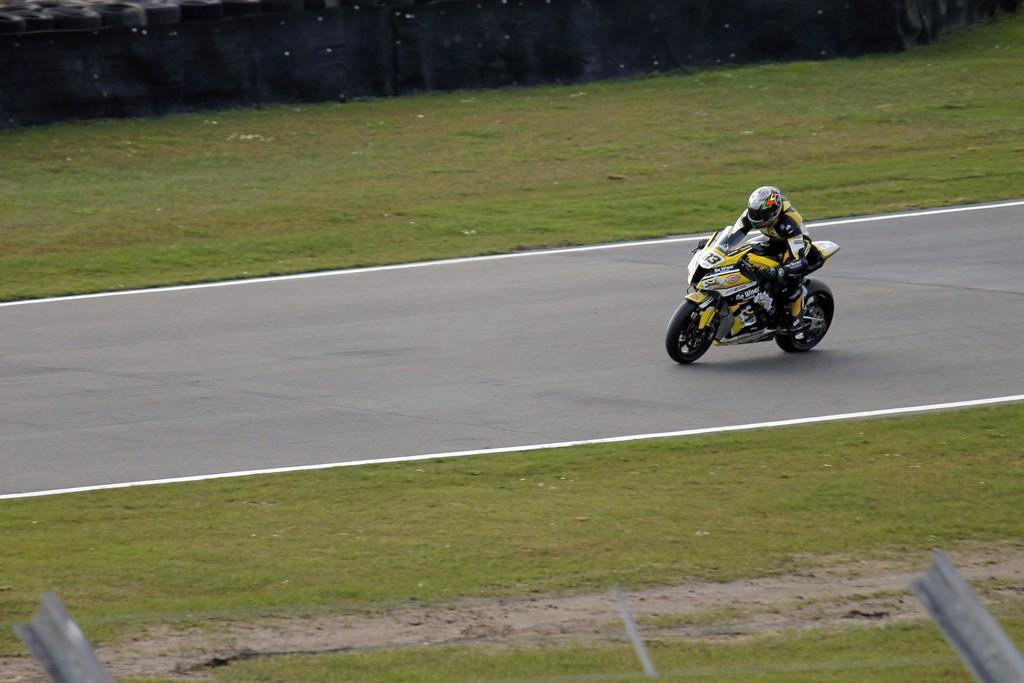In one or two sentences, can you explain what this image depicts? In this image I can see a person riding a bike and the bike is in yellow color and I can see grass in green color. 